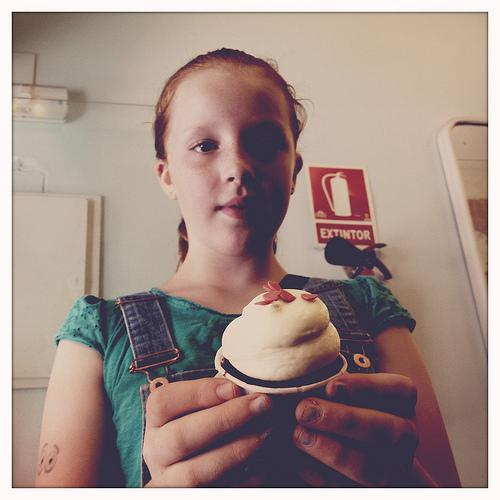Question: what is she holding?
Choices:
A. Ice cream.
B. Ball.
C. Dress.
D. Phone.
Answer with the letter. Answer: A Question: what is her hair color?
Choices:
A. Ribbon.
B. Stick.
C. Ginger.
D. Glasses.
Answer with the letter. Answer: C Question: when will she eat it?
Choices:
A. Tomorrow.
B. Night.
C. Soon.
D. Now.
Answer with the letter. Answer: C Question: how is she standing?
Choices:
A. Bent over.
B. To the right side.
C. Scared.
D. Posing.
Answer with the letter. Answer: D Question: who is there?
Choices:
A. A baby.
B. Young girl.
C. A mother.
D. A father.
Answer with the letter. Answer: B 